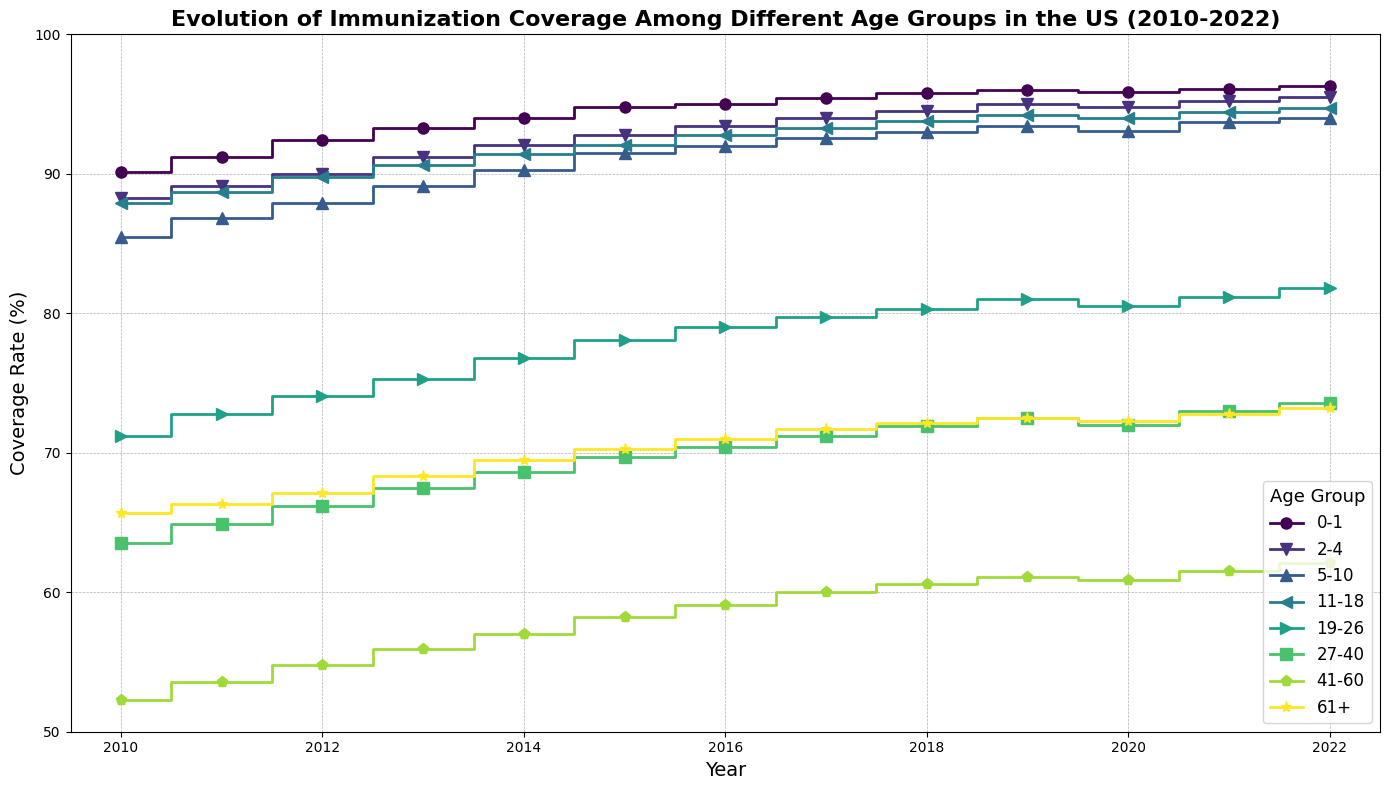Which age group had the highest immunization coverage in 2010? Look at the data points for 2010 and identify the age group with the highest coverage rate. The age group 0-1 had the highest immunization coverage at 90.1% in 2010.
Answer: 0-1 By how much did the immunization coverage rate for age group 19-26 change from 2010 to 2022? Find the coverage rates for the age group 19-26 in 2010 and 2022, then calculate the difference. In 2010, it was 71.2%, and in 2022, it was 81.8%. So, the change is 81.8% - 71.2% = 10.6%.
Answer: 10.6% What is the average immunization coverage for the age group 0-1 from 2010 to 2022? Sum the coverage rates for the age group 0-1 for each year from 2010 to 2022, then divide by the number of years. The sum is (90.1 + 91.2 + 92.4 + 93.3 + 94.0 + 94.8 + 95.0 + 95.4 + 95.8 + 96.0 + 95.9 + 96.1 + 96.3) = 1222.5. The number of years is 13, so the average is 1222.5 / 13 ≈ 94.04%.
Answer: 94.04% In which year did the age group 27-40 surpass the 70% coverage rate for the first time? Look at the coverage rates for the age group 27-40 in each year and identify the first year when it becomes greater than or equal to 70%. In 2016, the coverage rate was 70.4%, which is the first year it surpassed 70%.
Answer: 2016 Between 2015 and 2020, which age group showed the least increase in immunization coverage? Calculate the difference in coverage rates from 2015 to 2020 for each age group and identify the one with the smallest increase. For 2015 to 2020: 0-1 increased by 0.9%, 2-4 increased by 2.0%, 5-10 increased by 1.6%, 11-18 increased by 1.9%, 19-26 increased by 2.4%, 27-40 increased by 2.3%, 41-60 increased by 2.7%, 61+ increased by 2.0%. The age group 0-1 showed the least increase of 0.9%.
Answer: 0-1 Which age group showed the most significant decrease in coverage rate during the observation period? Identify any decreases in coverage for each age group and find the largest one. The age group 61+ had fluctuations but did not have a significant overall decrease, the biggest observed decrease was in age group 41-60 from 2010 (52.3%) to 2011 (53.6%).
Answer: No significant overall decrease Which two age groups had the closest immunization coverage rates in 2021? Check the immunization coverage rates for all age groups in 2021 and identify the two closest values. The age groups 19-26 (81.2%) and 61+ (72.8%) seem close, but 27-40 is closer to 19-26 at 73.0%. Hence, the closest two are 27-40 and 19-26.
Answer: 27-40 and 19-26 What is the trend for the immunization coverage rate for the age group 61+ from 2010 to 2022? Observe the line representing the age group 61+ from 2010 to 2022. The trend shows a gradual increase from 65.7% in 2010 to 73.2% in 2022.
Answer: Gradual increase Compare the coverage rate of age groups 0-1 and 41-60 in 2013. Which one is higher? Look at the coverage rates for both age groups in 2013. 0-1 has a coverage rate of 93.3%, while 41-60 has a coverage rate of 55.9%, making 0-1 higher.
Answer: 0-1 How does the trend in immunization coverage for age group 5-10 compare to that for age group 11-18 from 2010 to 2022? Analyze the trend lines for the age groups 5-10 and 11-18 from 2010 to 2022. Both show a generally increasing trend, with fluctuations. However, 11-18 consistently stays higher in coverage than 5-10 throughout the period.
Answer: Both increasing, 11-18 consistently higher 